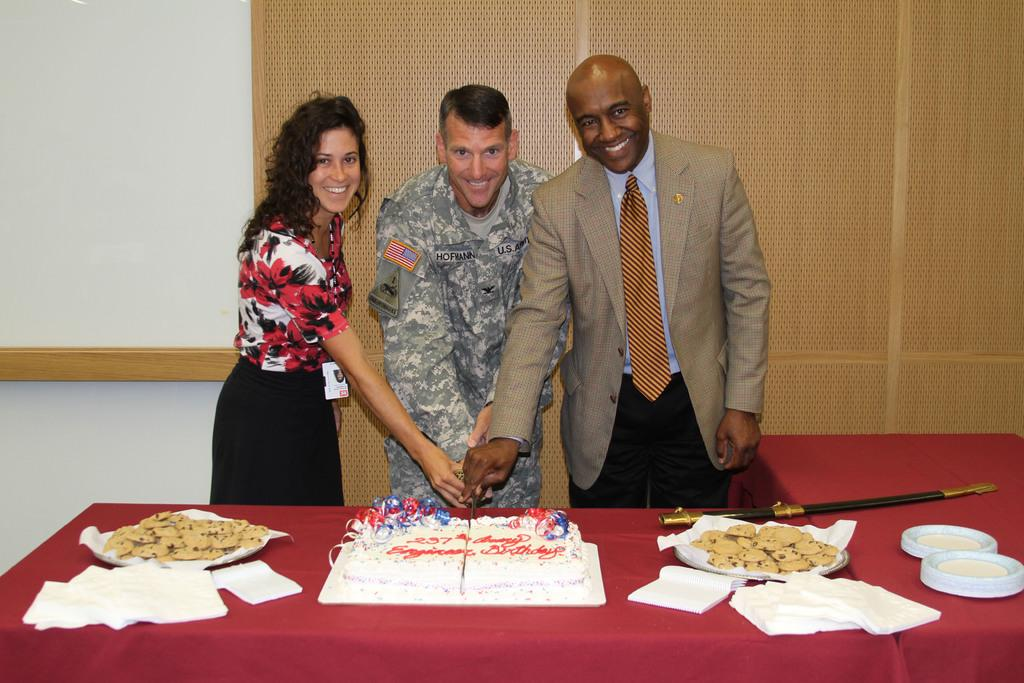How many people are in the image? There are three persons in the image. What are the persons doing in the image? The persons are cutting a cake. Where is the cake located in the image? The cake is placed on a table. What other items can be seen on the table? There are biscuits and tissue papers on the table. What direction is the coach facing in the image? There is no coach present in the image. 